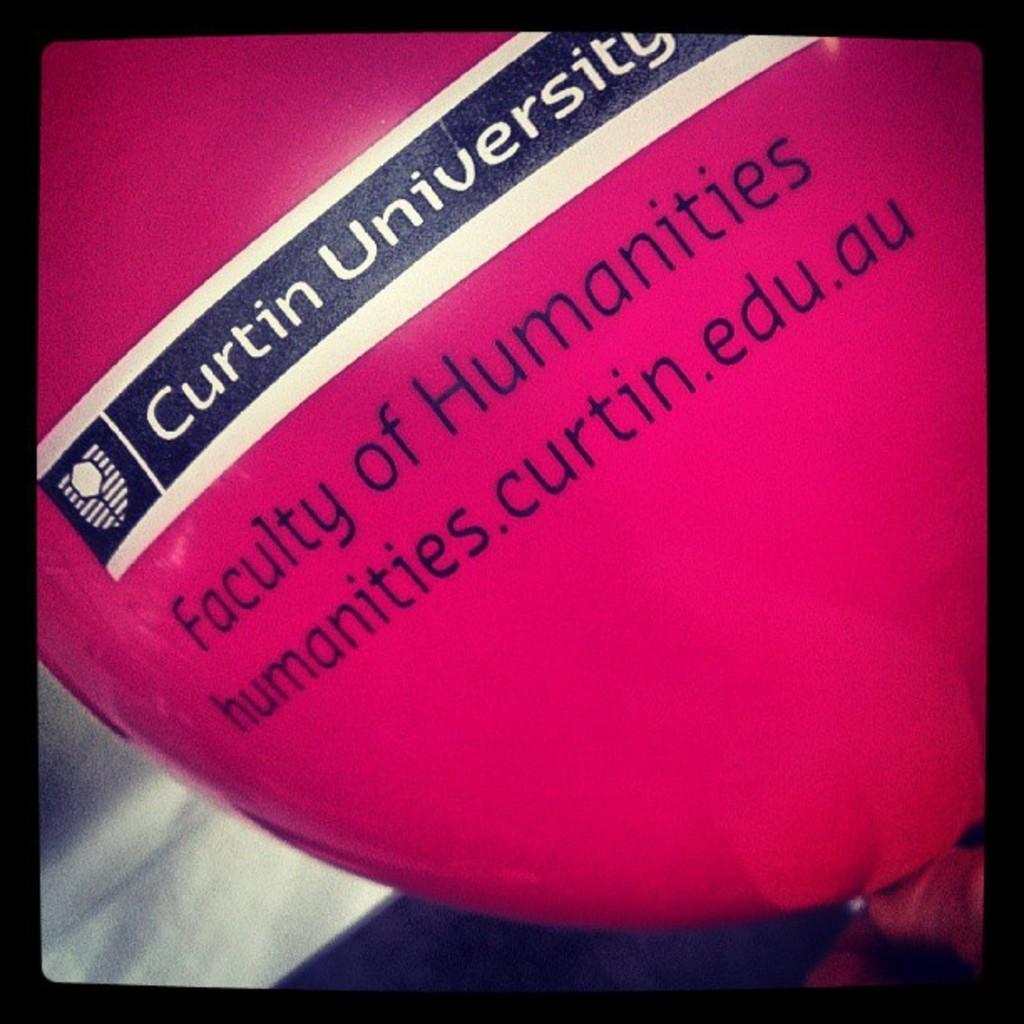Please provide a concise description of this image. In this picture we can see a balloon and some text written on it. 